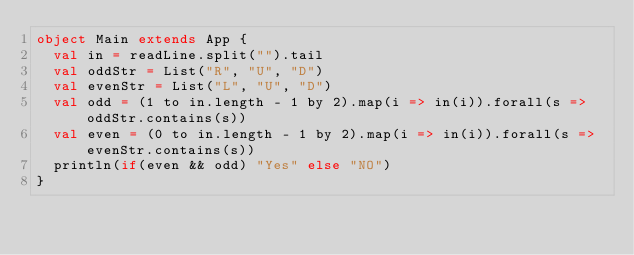Convert code to text. <code><loc_0><loc_0><loc_500><loc_500><_Scala_>object Main extends App {	
  val in = readLine.split("").tail
  val oddStr = List("R", "U", "D")
  val evenStr = List("L", "U", "D")
  val odd = (1 to in.length - 1 by 2).map(i => in(i)).forall(s => oddStr.contains(s))
  val even = (0 to in.length - 1 by 2).map(i => in(i)).forall(s => evenStr.contains(s))
  println(if(even && odd) "Yes" else "NO")
}</code> 